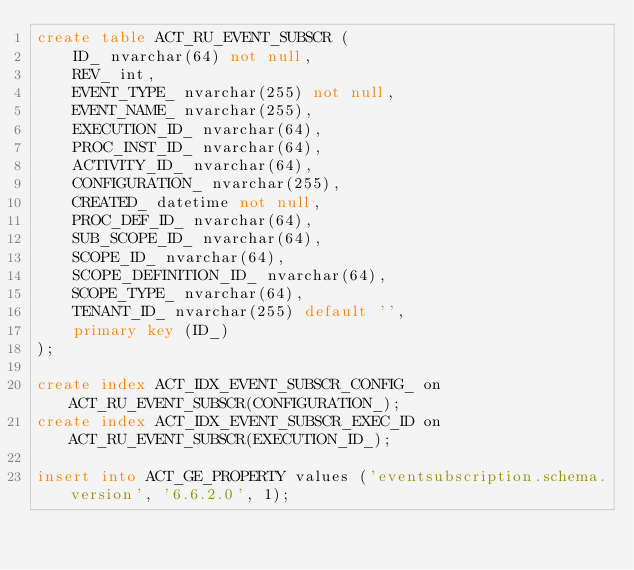Convert code to text. <code><loc_0><loc_0><loc_500><loc_500><_SQL_>create table ACT_RU_EVENT_SUBSCR (
    ID_ nvarchar(64) not null,
    REV_ int,
    EVENT_TYPE_ nvarchar(255) not null,
    EVENT_NAME_ nvarchar(255),
    EXECUTION_ID_ nvarchar(64),
    PROC_INST_ID_ nvarchar(64),
    ACTIVITY_ID_ nvarchar(64),
    CONFIGURATION_ nvarchar(255),
    CREATED_ datetime not null,
    PROC_DEF_ID_ nvarchar(64),
    SUB_SCOPE_ID_ nvarchar(64),
    SCOPE_ID_ nvarchar(64),
    SCOPE_DEFINITION_ID_ nvarchar(64),
    SCOPE_TYPE_ nvarchar(64),
    TENANT_ID_ nvarchar(255) default '',
    primary key (ID_)
);

create index ACT_IDX_EVENT_SUBSCR_CONFIG_ on ACT_RU_EVENT_SUBSCR(CONFIGURATION_);
create index ACT_IDX_EVENT_SUBSCR_EXEC_ID on ACT_RU_EVENT_SUBSCR(EXECUTION_ID_);

insert into ACT_GE_PROPERTY values ('eventsubscription.schema.version', '6.6.2.0', 1);</code> 